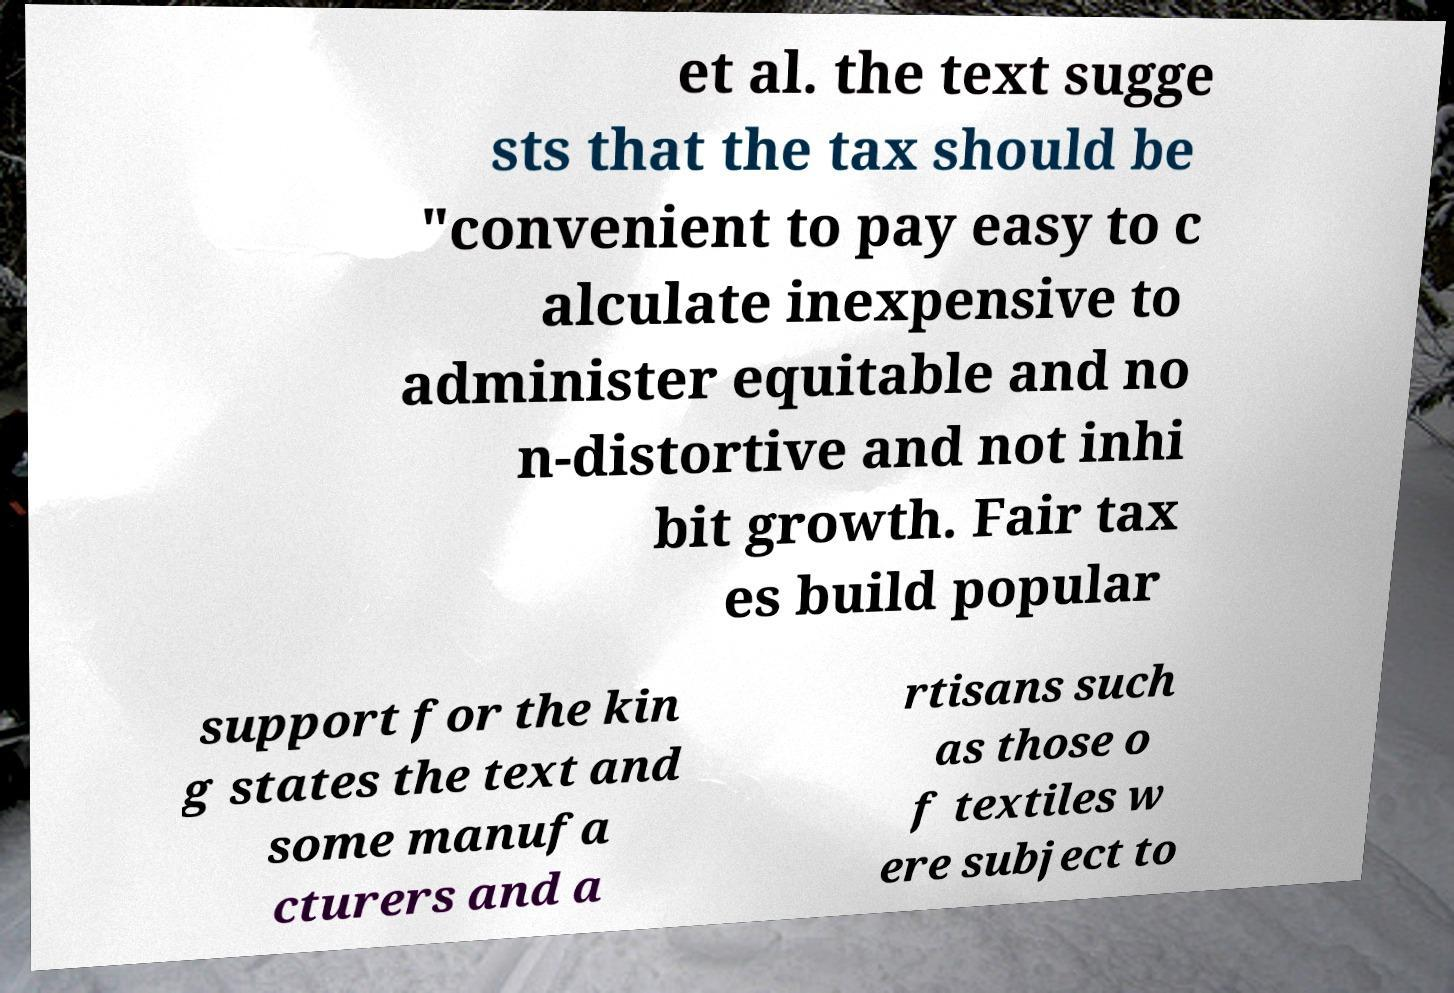Could you extract and type out the text from this image? et al. the text sugge sts that the tax should be "convenient to pay easy to c alculate inexpensive to administer equitable and no n-distortive and not inhi bit growth. Fair tax es build popular support for the kin g states the text and some manufa cturers and a rtisans such as those o f textiles w ere subject to 